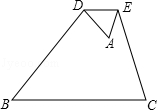As shown in the figure, turn △ABC along DE, DE ∥ BC, if \frac{AD}{BD} = \frac{1.0}{3.0}, BC = u, then the length of DE is 2.0. What is the value of the unknown variable u? To solve for the length of BC, identified as 'u' in the question, we utilize the properties of similar triangles and the proportionality of their corresponding sides. Since DE is parallel to BC, creating a smaller triangle ADE within triangle ABC, we identify these two triangles as similar. The ratio of corresponding sides in similar triangles is constant; hence, DE/BC equals AD/AB. Given AD/BD is 1/3 and DE is 2.0, we infer AB to be AD + BD which is 1 part + 3 parts, equalling 4 parts in total. By considering the length of DE to be 2.0, we can set up the proportion 2.0/BC = 1.0/4.0. Solving for BC (u) involves cross-multiplying to find that BC equals 8.0. Therefore, the value of the unknown variable 'u' is 8.0 units, aligning with Option A. 